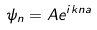<formula> <loc_0><loc_0><loc_500><loc_500>\psi _ { n } = A e ^ { i k n a }</formula> 